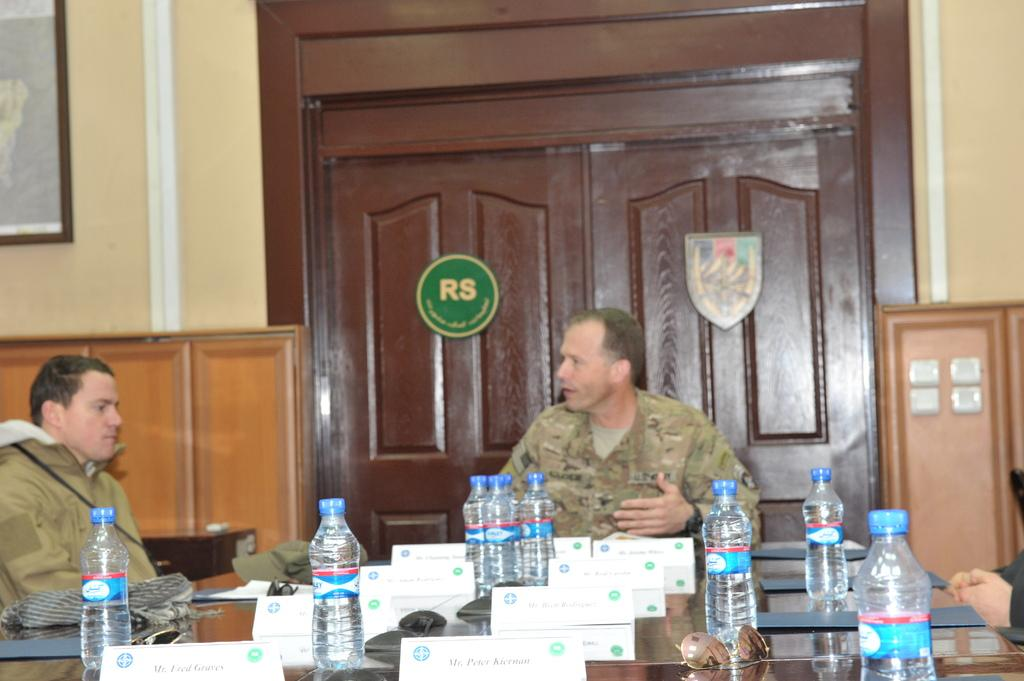<image>
Present a compact description of the photo's key features. Soldier in a corporate board meeting room which features brown doors that have RS written on them. 